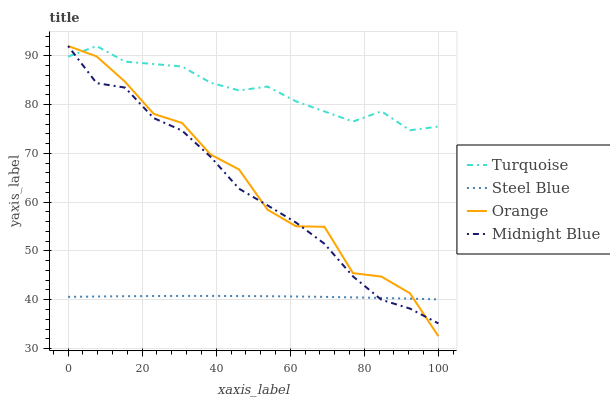Does Steel Blue have the minimum area under the curve?
Answer yes or no. Yes. Does Turquoise have the maximum area under the curve?
Answer yes or no. Yes. Does Turquoise have the minimum area under the curve?
Answer yes or no. No. Does Steel Blue have the maximum area under the curve?
Answer yes or no. No. Is Steel Blue the smoothest?
Answer yes or no. Yes. Is Orange the roughest?
Answer yes or no. Yes. Is Turquoise the smoothest?
Answer yes or no. No. Is Turquoise the roughest?
Answer yes or no. No. Does Steel Blue have the lowest value?
Answer yes or no. No. Does Steel Blue have the highest value?
Answer yes or no. No. Is Steel Blue less than Turquoise?
Answer yes or no. Yes. Is Turquoise greater than Steel Blue?
Answer yes or no. Yes. Does Steel Blue intersect Turquoise?
Answer yes or no. No. 